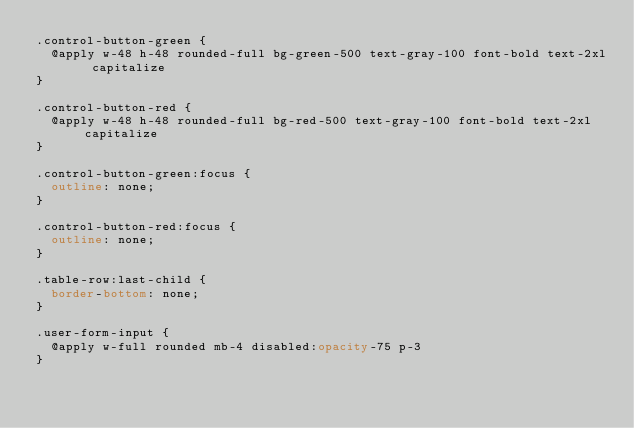Convert code to text. <code><loc_0><loc_0><loc_500><loc_500><_CSS_>.control-button-green {
	@apply w-48 h-48 rounded-full bg-green-500 text-gray-100 font-bold text-2xl capitalize
}

.control-button-red {
	@apply w-48 h-48 rounded-full bg-red-500 text-gray-100 font-bold text-2xl capitalize
}

.control-button-green:focus {
	outline: none;
}

.control-button-red:focus {
	outline: none;
}

.table-row:last-child {
	border-bottom: none;
}

.user-form-input {
	@apply w-full rounded mb-4 disabled:opacity-75 p-3
}</code> 